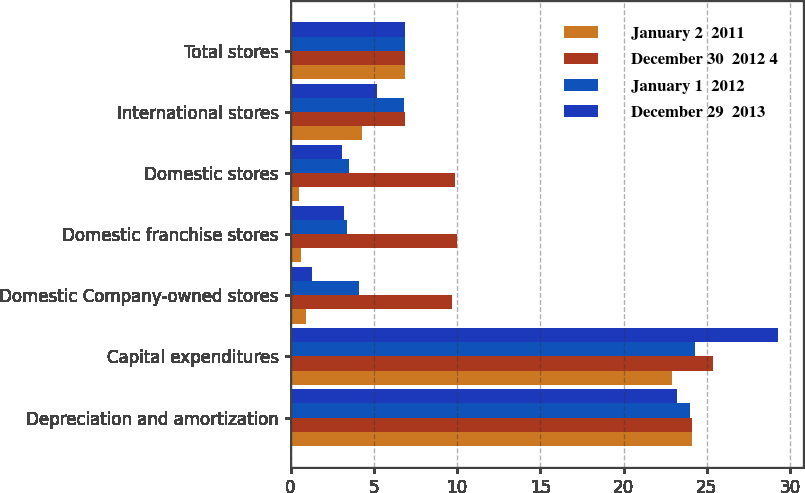Convert chart to OTSL. <chart><loc_0><loc_0><loc_500><loc_500><stacked_bar_chart><ecel><fcel>Depreciation and amortization<fcel>Capital expenditures<fcel>Domestic Company-owned stores<fcel>Domestic franchise stores<fcel>Domestic stores<fcel>International stores<fcel>Total stores<nl><fcel>January 2  2011<fcel>24.1<fcel>22.9<fcel>0.9<fcel>0.6<fcel>0.5<fcel>4.3<fcel>6.85<nl><fcel>December 30  2012 4<fcel>24.1<fcel>25.4<fcel>9.7<fcel>10<fcel>9.9<fcel>6.9<fcel>6.85<nl><fcel>January 1  2012<fcel>24<fcel>24.3<fcel>4.1<fcel>3.4<fcel>3.5<fcel>6.8<fcel>6.85<nl><fcel>December 29  2013<fcel>23.2<fcel>29.3<fcel>1.3<fcel>3.2<fcel>3.1<fcel>5.2<fcel>6.85<nl></chart> 